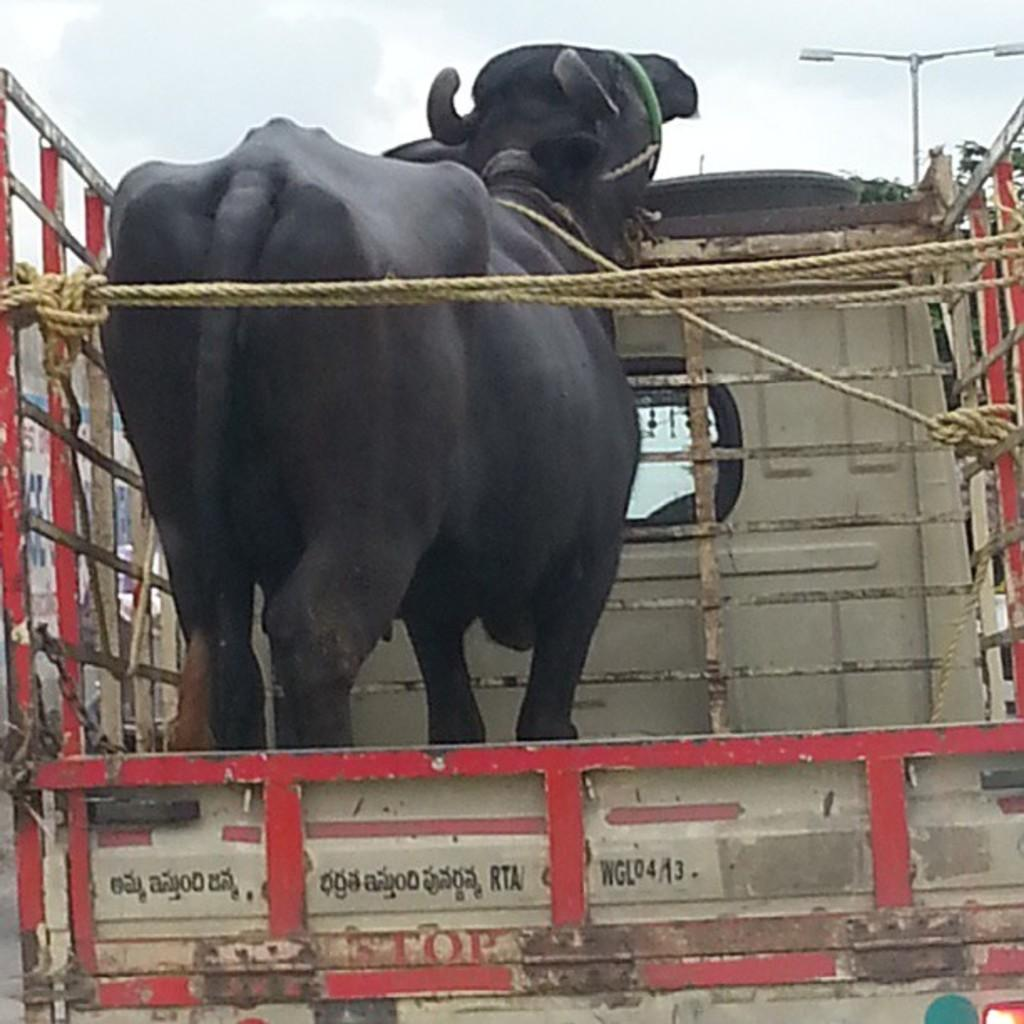What type of animal is in the image? There is a black color buffalo in the image. Where is the buffalo located? The buffalo is in a vehicle. What can be seen in the background of the image? There is a street light in the background of the image. What is visible at the top of the image? The sky is visible at the top of the image. How many books can be seen on the buffalo's back in the image? There are no books visible on the buffalo's back in the image. What type of trees are surrounding the vehicle in the image? There are no trees visible in the image. 